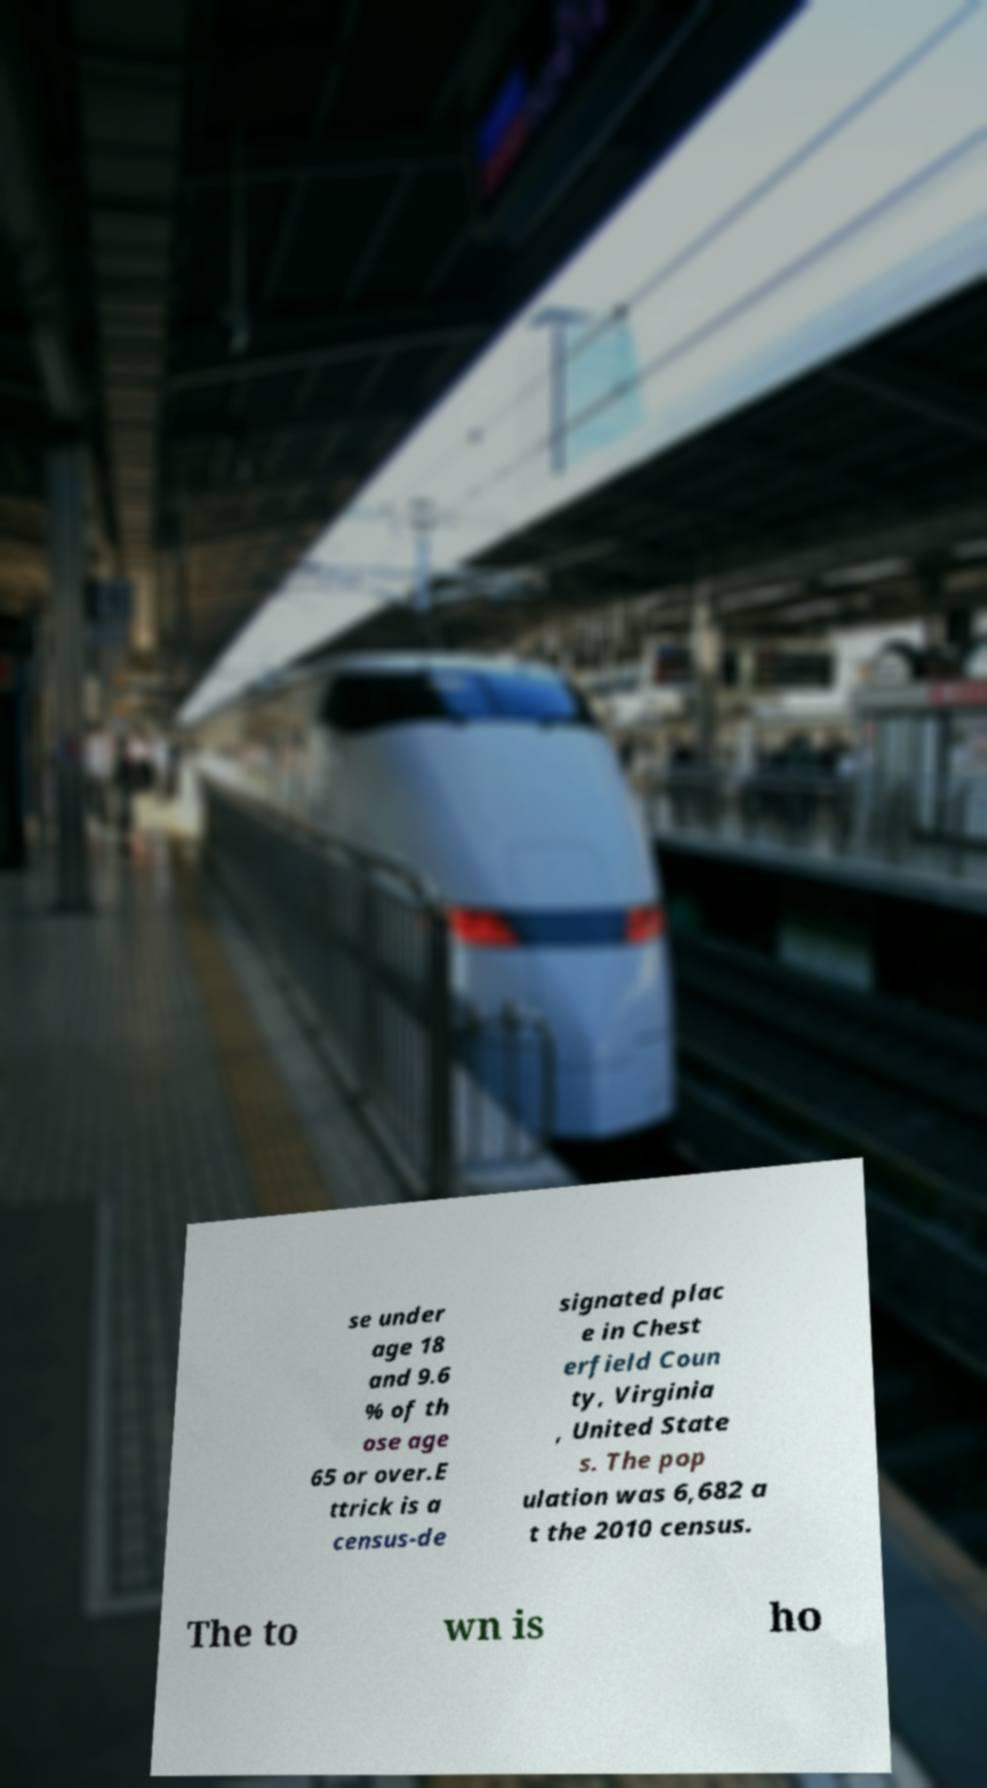For documentation purposes, I need the text within this image transcribed. Could you provide that? se under age 18 and 9.6 % of th ose age 65 or over.E ttrick is a census-de signated plac e in Chest erfield Coun ty, Virginia , United State s. The pop ulation was 6,682 a t the 2010 census. The to wn is ho 